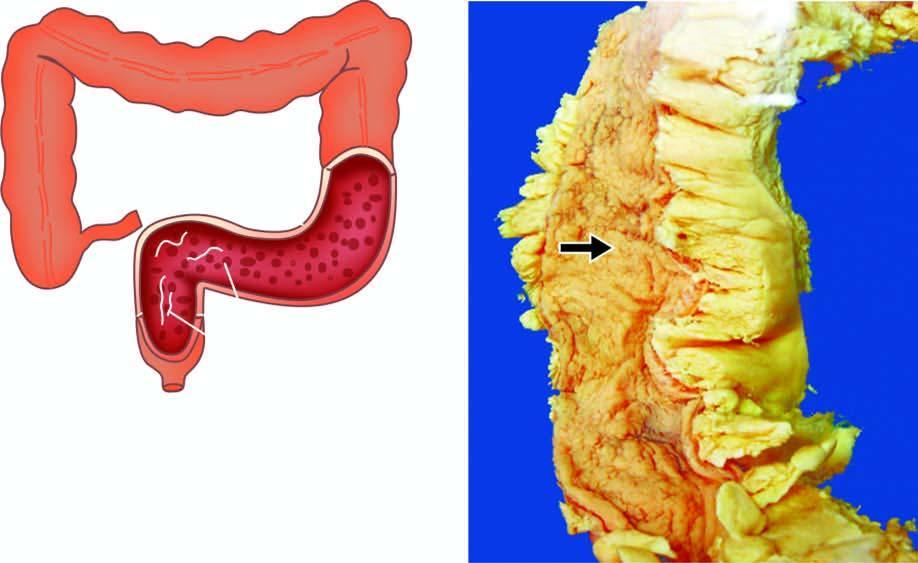re the ulcers superficial with intervening inflammatory pseudopolyps?
Answer the question using a single word or phrase. Yes 